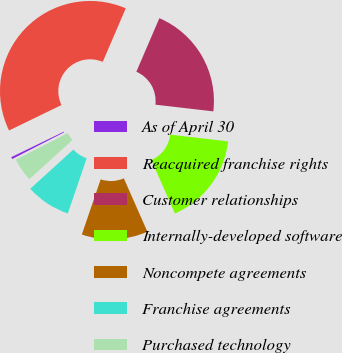<chart> <loc_0><loc_0><loc_500><loc_500><pie_chart><fcel>As of April 30<fcel>Reacquired franchise rights<fcel>Customer relationships<fcel>Internally-developed software<fcel>Noncompete agreements<fcel>Franchise agreements<fcel>Purchased technology<nl><fcel>0.36%<fcel>38.65%<fcel>20.37%<fcel>16.55%<fcel>11.85%<fcel>8.02%<fcel>4.19%<nl></chart> 